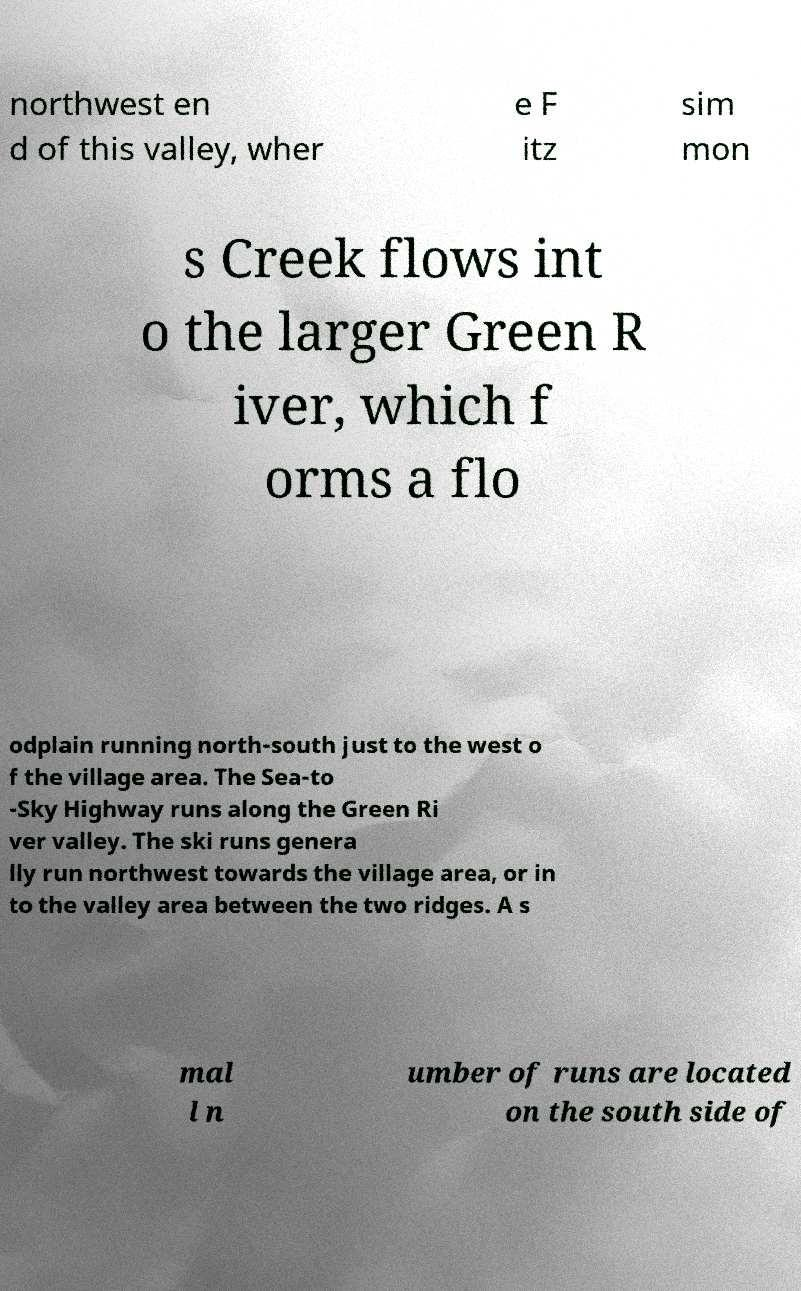Can you accurately transcribe the text from the provided image for me? northwest en d of this valley, wher e F itz sim mon s Creek flows int o the larger Green R iver, which f orms a flo odplain running north-south just to the west o f the village area. The Sea-to -Sky Highway runs along the Green Ri ver valley. The ski runs genera lly run northwest towards the village area, or in to the valley area between the two ridges. A s mal l n umber of runs are located on the south side of 